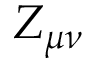Convert formula to latex. <formula><loc_0><loc_0><loc_500><loc_500>Z _ { \mu \nu }</formula> 